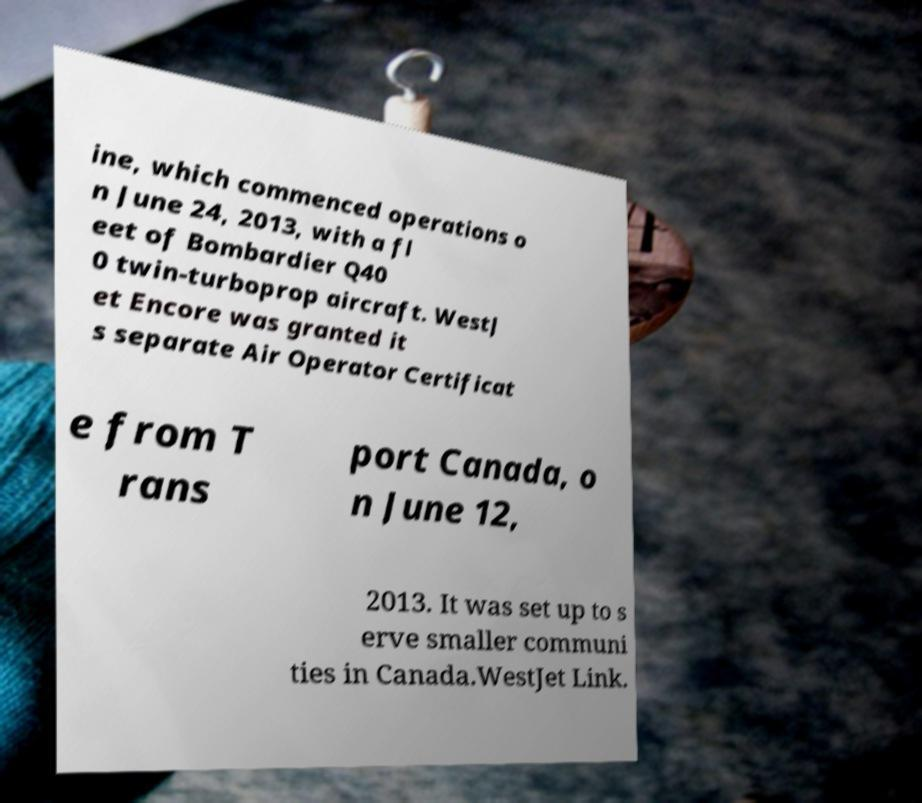What messages or text are displayed in this image? I need them in a readable, typed format. ine, which commenced operations o n June 24, 2013, with a fl eet of Bombardier Q40 0 twin-turboprop aircraft. WestJ et Encore was granted it s separate Air Operator Certificat e from T rans port Canada, o n June 12, 2013. It was set up to s erve smaller communi ties in Canada.WestJet Link. 